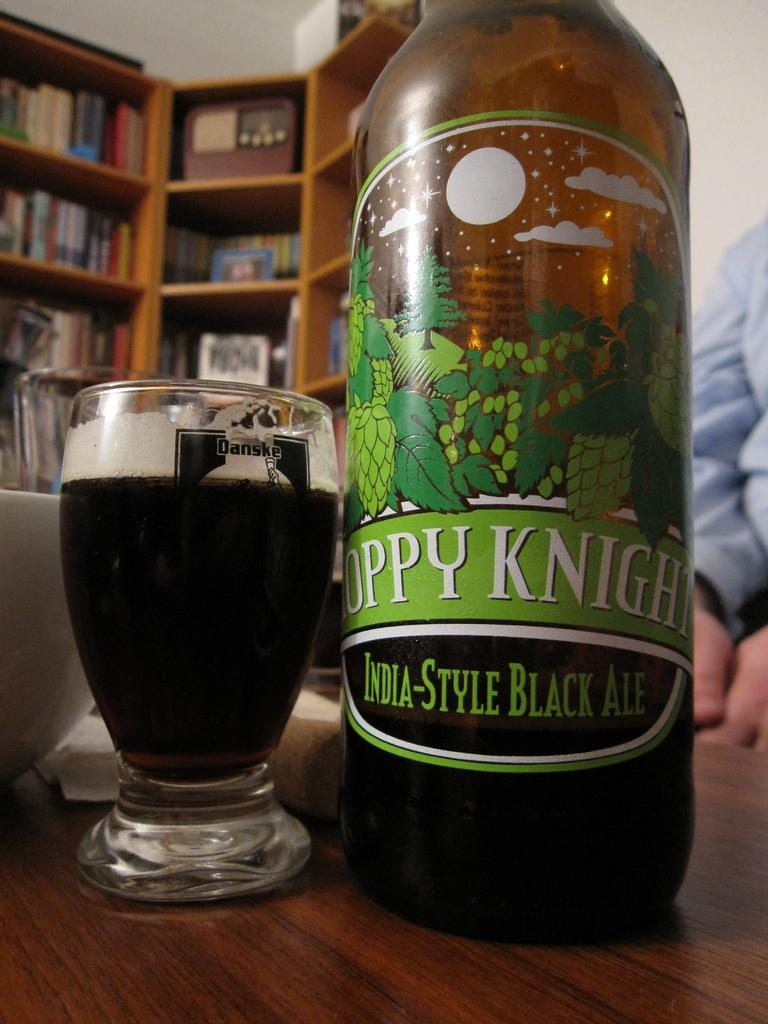Provide a one-sentence caption for the provided image. India-Style Ale bottle and India-Style ale poured in a Danske glass. 